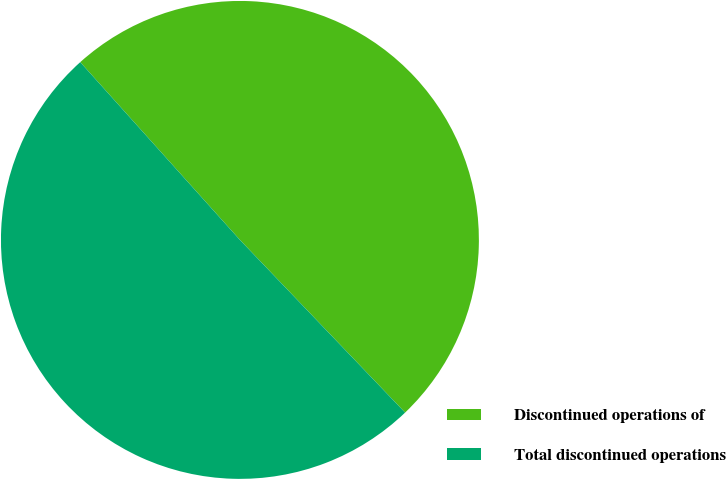Convert chart. <chart><loc_0><loc_0><loc_500><loc_500><pie_chart><fcel>Discontinued operations of<fcel>Total discontinued operations<nl><fcel>49.5%<fcel>50.5%<nl></chart> 